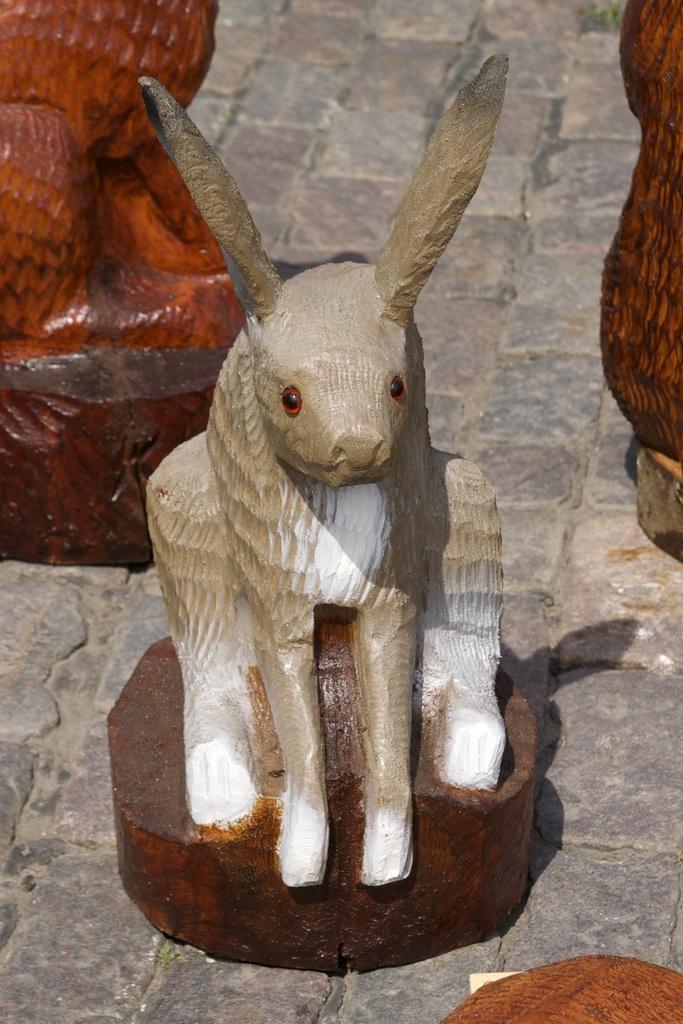How would you summarize this image in a sentence or two? This image consists of a statue. This is an animal statue. 